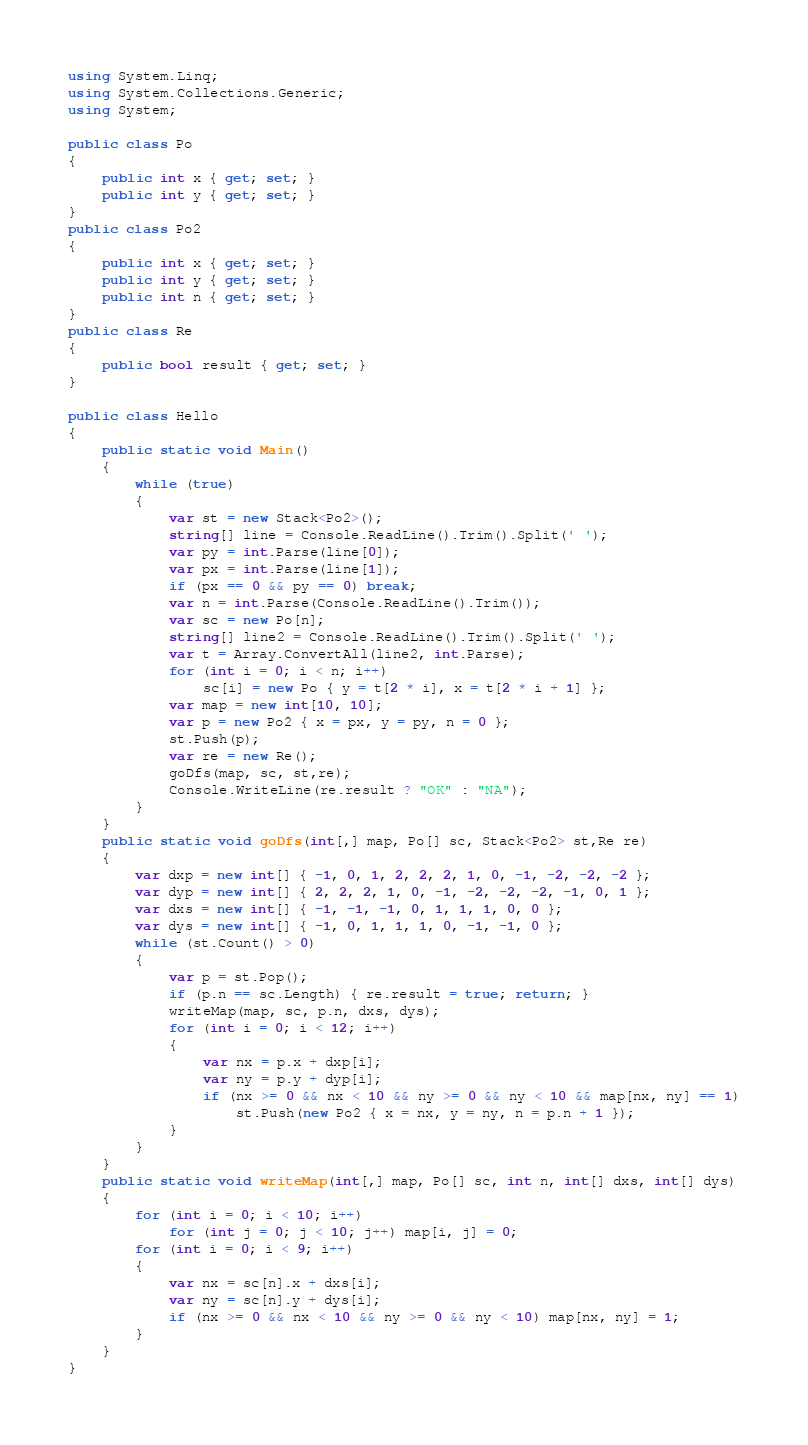<code> <loc_0><loc_0><loc_500><loc_500><_C#_>using System.Linq;
using System.Collections.Generic;
using System;

public class Po
{
    public int x { get; set; }
    public int y { get; set; }
}
public class Po2
{
    public int x { get; set; }
    public int y { get; set; }
    public int n { get; set; }
}
public class Re
{
    public bool result { get; set; }
}

public class Hello
{
    public static void Main()
    {
        while (true)
        {
            var st = new Stack<Po2>();
            string[] line = Console.ReadLine().Trim().Split(' ');
            var py = int.Parse(line[0]);
            var px = int.Parse(line[1]);
            if (px == 0 && py == 0) break;
            var n = int.Parse(Console.ReadLine().Trim());
            var sc = new Po[n];
            string[] line2 = Console.ReadLine().Trim().Split(' ');
            var t = Array.ConvertAll(line2, int.Parse);
            for (int i = 0; i < n; i++)
                sc[i] = new Po { y = t[2 * i], x = t[2 * i + 1] };
            var map = new int[10, 10];
            var p = new Po2 { x = px, y = py, n = 0 };
            st.Push(p);
            var re = new Re();
            goDfs(map, sc, st,re);
            Console.WriteLine(re.result ? "OK" : "NA");
        }
    }
    public static void goDfs(int[,] map, Po[] sc, Stack<Po2> st,Re re)
    {
        var dxp = new int[] { -1, 0, 1, 2, 2, 2, 1, 0, -1, -2, -2, -2 };
        var dyp = new int[] { 2, 2, 2, 1, 0, -1, -2, -2, -2, -1, 0, 1 };
        var dxs = new int[] { -1, -1, -1, 0, 1, 1, 1, 0, 0 };
        var dys = new int[] { -1, 0, 1, 1, 1, 0, -1, -1, 0 };
        while (st.Count() > 0)
        {
            var p = st.Pop();
            if (p.n == sc.Length) { re.result = true; return; }
            writeMap(map, sc, p.n, dxs, dys);
            for (int i = 0; i < 12; i++)
            {
                var nx = p.x + dxp[i];
                var ny = p.y + dyp[i];
                if (nx >= 0 && nx < 10 && ny >= 0 && ny < 10 && map[nx, ny] == 1)
                    st.Push(new Po2 { x = nx, y = ny, n = p.n + 1 });
            }
        }
    }
    public static void writeMap(int[,] map, Po[] sc, int n, int[] dxs, int[] dys)
    {
        for (int i = 0; i < 10; i++)
            for (int j = 0; j < 10; j++) map[i, j] = 0;
        for (int i = 0; i < 9; i++)
        {
            var nx = sc[n].x + dxs[i];
            var ny = sc[n].y + dys[i];
            if (nx >= 0 && nx < 10 && ny >= 0 && ny < 10) map[nx, ny] = 1;
        }
    }
}</code> 